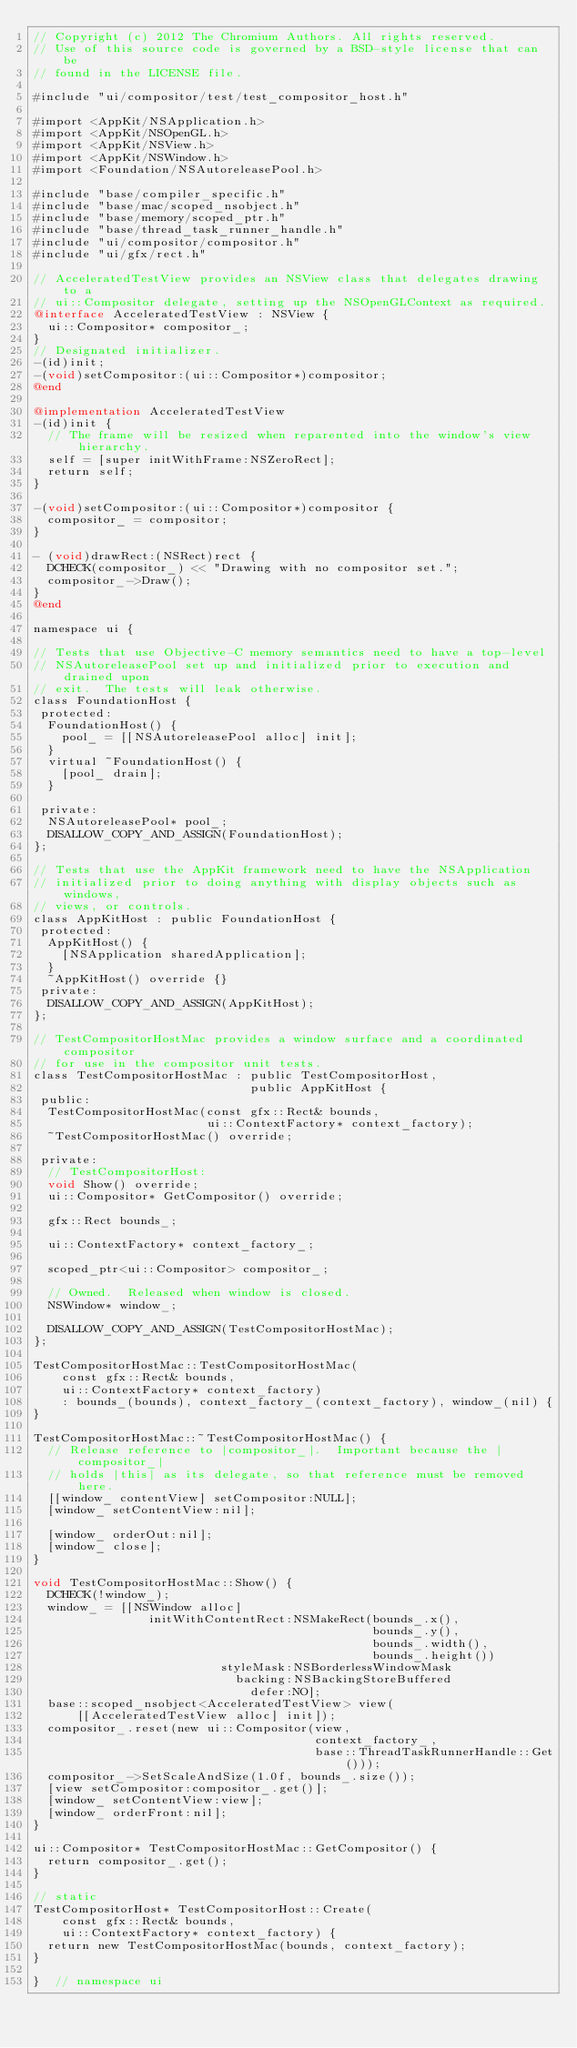Convert code to text. <code><loc_0><loc_0><loc_500><loc_500><_ObjectiveC_>// Copyright (c) 2012 The Chromium Authors. All rights reserved.
// Use of this source code is governed by a BSD-style license that can be
// found in the LICENSE file.

#include "ui/compositor/test/test_compositor_host.h"

#import <AppKit/NSApplication.h>
#import <AppKit/NSOpenGL.h>
#import <AppKit/NSView.h>
#import <AppKit/NSWindow.h>
#import <Foundation/NSAutoreleasePool.h>

#include "base/compiler_specific.h"
#include "base/mac/scoped_nsobject.h"
#include "base/memory/scoped_ptr.h"
#include "base/thread_task_runner_handle.h"
#include "ui/compositor/compositor.h"
#include "ui/gfx/rect.h"

// AcceleratedTestView provides an NSView class that delegates drawing to a
// ui::Compositor delegate, setting up the NSOpenGLContext as required.
@interface AcceleratedTestView : NSView {
  ui::Compositor* compositor_;
}
// Designated initializer.
-(id)init;
-(void)setCompositor:(ui::Compositor*)compositor;
@end

@implementation AcceleratedTestView
-(id)init {
  // The frame will be resized when reparented into the window's view hierarchy.
  self = [super initWithFrame:NSZeroRect];
  return self;
}

-(void)setCompositor:(ui::Compositor*)compositor {
  compositor_ = compositor;
}

- (void)drawRect:(NSRect)rect {
  DCHECK(compositor_) << "Drawing with no compositor set.";
  compositor_->Draw();
}
@end

namespace ui {

// Tests that use Objective-C memory semantics need to have a top-level
// NSAutoreleasePool set up and initialized prior to execution and drained upon
// exit.  The tests will leak otherwise.
class FoundationHost {
 protected:
  FoundationHost() {
    pool_ = [[NSAutoreleasePool alloc] init];
  }
  virtual ~FoundationHost() {
    [pool_ drain];
  }

 private:
  NSAutoreleasePool* pool_;
  DISALLOW_COPY_AND_ASSIGN(FoundationHost);
};

// Tests that use the AppKit framework need to have the NSApplication
// initialized prior to doing anything with display objects such as windows,
// views, or controls.
class AppKitHost : public FoundationHost {
 protected:
  AppKitHost() {
    [NSApplication sharedApplication];
  }
  ~AppKitHost() override {}
 private:
  DISALLOW_COPY_AND_ASSIGN(AppKitHost);
};

// TestCompositorHostMac provides a window surface and a coordinated compositor
// for use in the compositor unit tests.
class TestCompositorHostMac : public TestCompositorHost,
                              public AppKitHost {
 public:
  TestCompositorHostMac(const gfx::Rect& bounds,
                        ui::ContextFactory* context_factory);
  ~TestCompositorHostMac() override;

 private:
  // TestCompositorHost:
  void Show() override;
  ui::Compositor* GetCompositor() override;

  gfx::Rect bounds_;

  ui::ContextFactory* context_factory_;

  scoped_ptr<ui::Compositor> compositor_;

  // Owned.  Released when window is closed.
  NSWindow* window_;

  DISALLOW_COPY_AND_ASSIGN(TestCompositorHostMac);
};

TestCompositorHostMac::TestCompositorHostMac(
    const gfx::Rect& bounds,
    ui::ContextFactory* context_factory)
    : bounds_(bounds), context_factory_(context_factory), window_(nil) {
}

TestCompositorHostMac::~TestCompositorHostMac() {
  // Release reference to |compositor_|.  Important because the |compositor_|
  // holds |this| as its delegate, so that reference must be removed here.
  [[window_ contentView] setCompositor:NULL];
  [window_ setContentView:nil];

  [window_ orderOut:nil];
  [window_ close];
}

void TestCompositorHostMac::Show() {
  DCHECK(!window_);
  window_ = [[NSWindow alloc]
                initWithContentRect:NSMakeRect(bounds_.x(),
                                               bounds_.y(),
                                               bounds_.width(),
                                               bounds_.height())
                          styleMask:NSBorderlessWindowMask
                            backing:NSBackingStoreBuffered
                              defer:NO];
  base::scoped_nsobject<AcceleratedTestView> view(
      [[AcceleratedTestView alloc] init]);
  compositor_.reset(new ui::Compositor(view,
                                       context_factory_,
                                       base::ThreadTaskRunnerHandle::Get()));
  compositor_->SetScaleAndSize(1.0f, bounds_.size());
  [view setCompositor:compositor_.get()];
  [window_ setContentView:view];
  [window_ orderFront:nil];
}

ui::Compositor* TestCompositorHostMac::GetCompositor() {
  return compositor_.get();
}

// static
TestCompositorHost* TestCompositorHost::Create(
    const gfx::Rect& bounds,
    ui::ContextFactory* context_factory) {
  return new TestCompositorHostMac(bounds, context_factory);
}

}  // namespace ui
</code> 